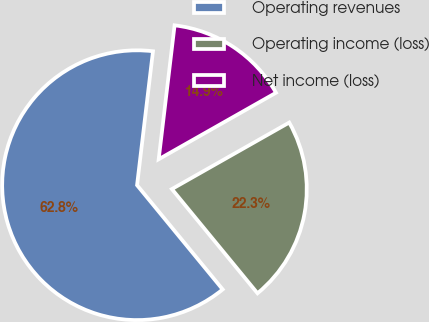Convert chart to OTSL. <chart><loc_0><loc_0><loc_500><loc_500><pie_chart><fcel>Operating revenues<fcel>Operating income (loss)<fcel>Net income (loss)<nl><fcel>62.83%<fcel>22.26%<fcel>14.91%<nl></chart> 